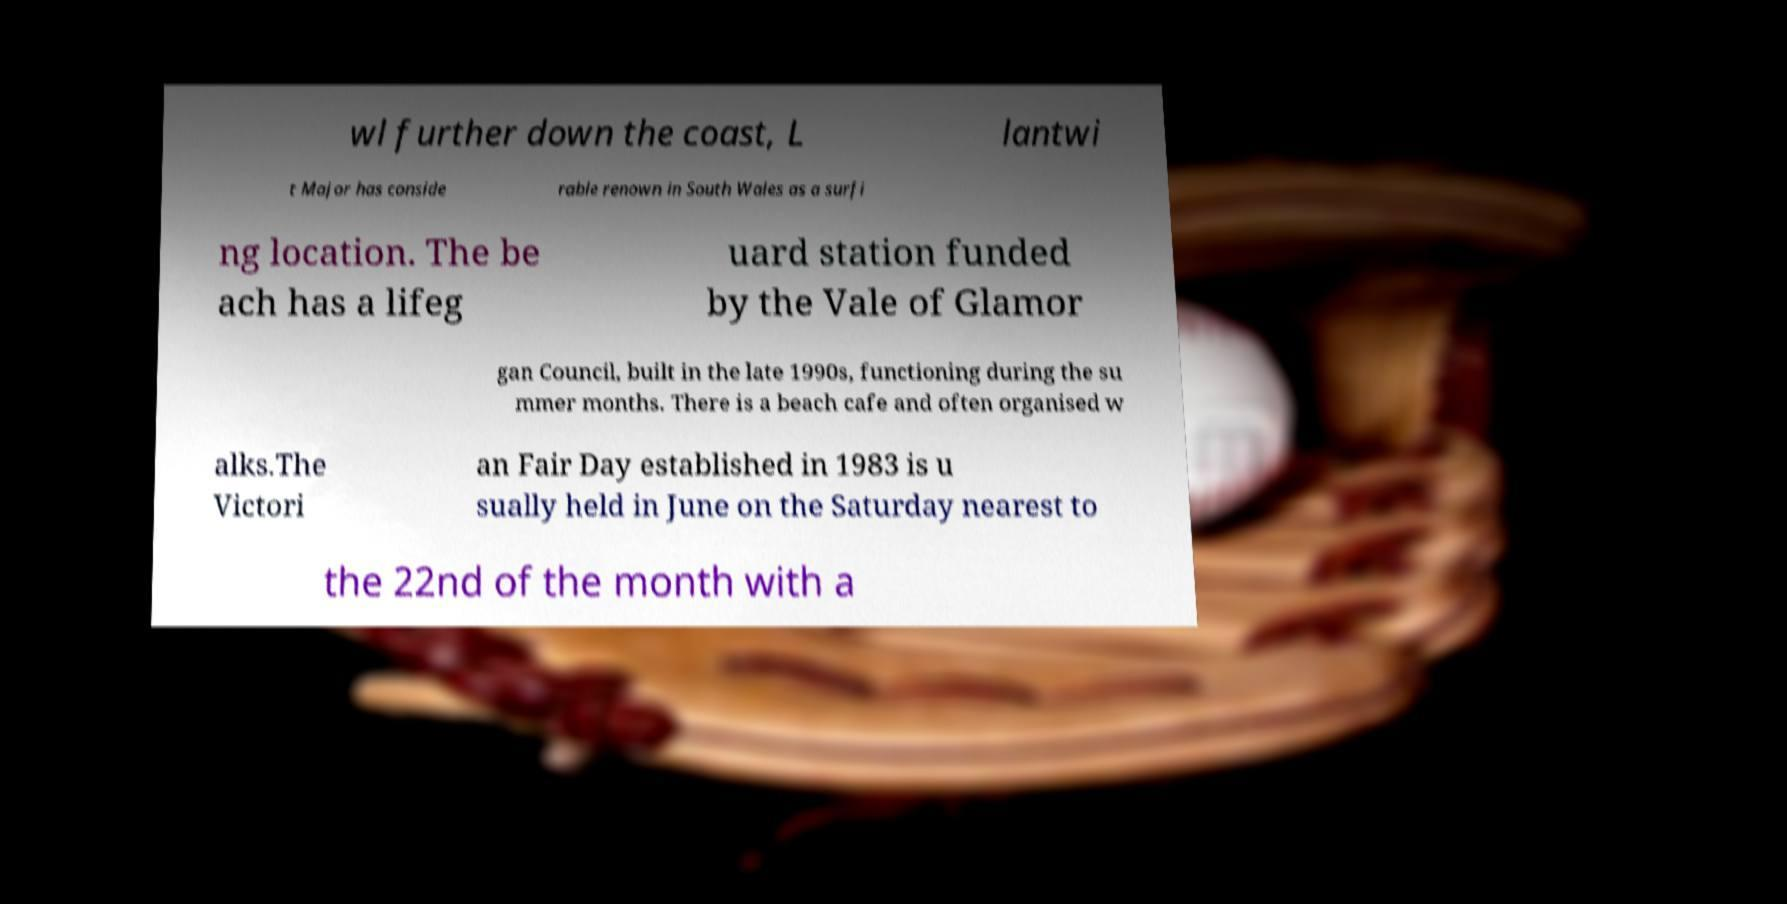Could you assist in decoding the text presented in this image and type it out clearly? wl further down the coast, L lantwi t Major has conside rable renown in South Wales as a surfi ng location. The be ach has a lifeg uard station funded by the Vale of Glamor gan Council, built in the late 1990s, functioning during the su mmer months. There is a beach cafe and often organised w alks.The Victori an Fair Day established in 1983 is u sually held in June on the Saturday nearest to the 22nd of the month with a 